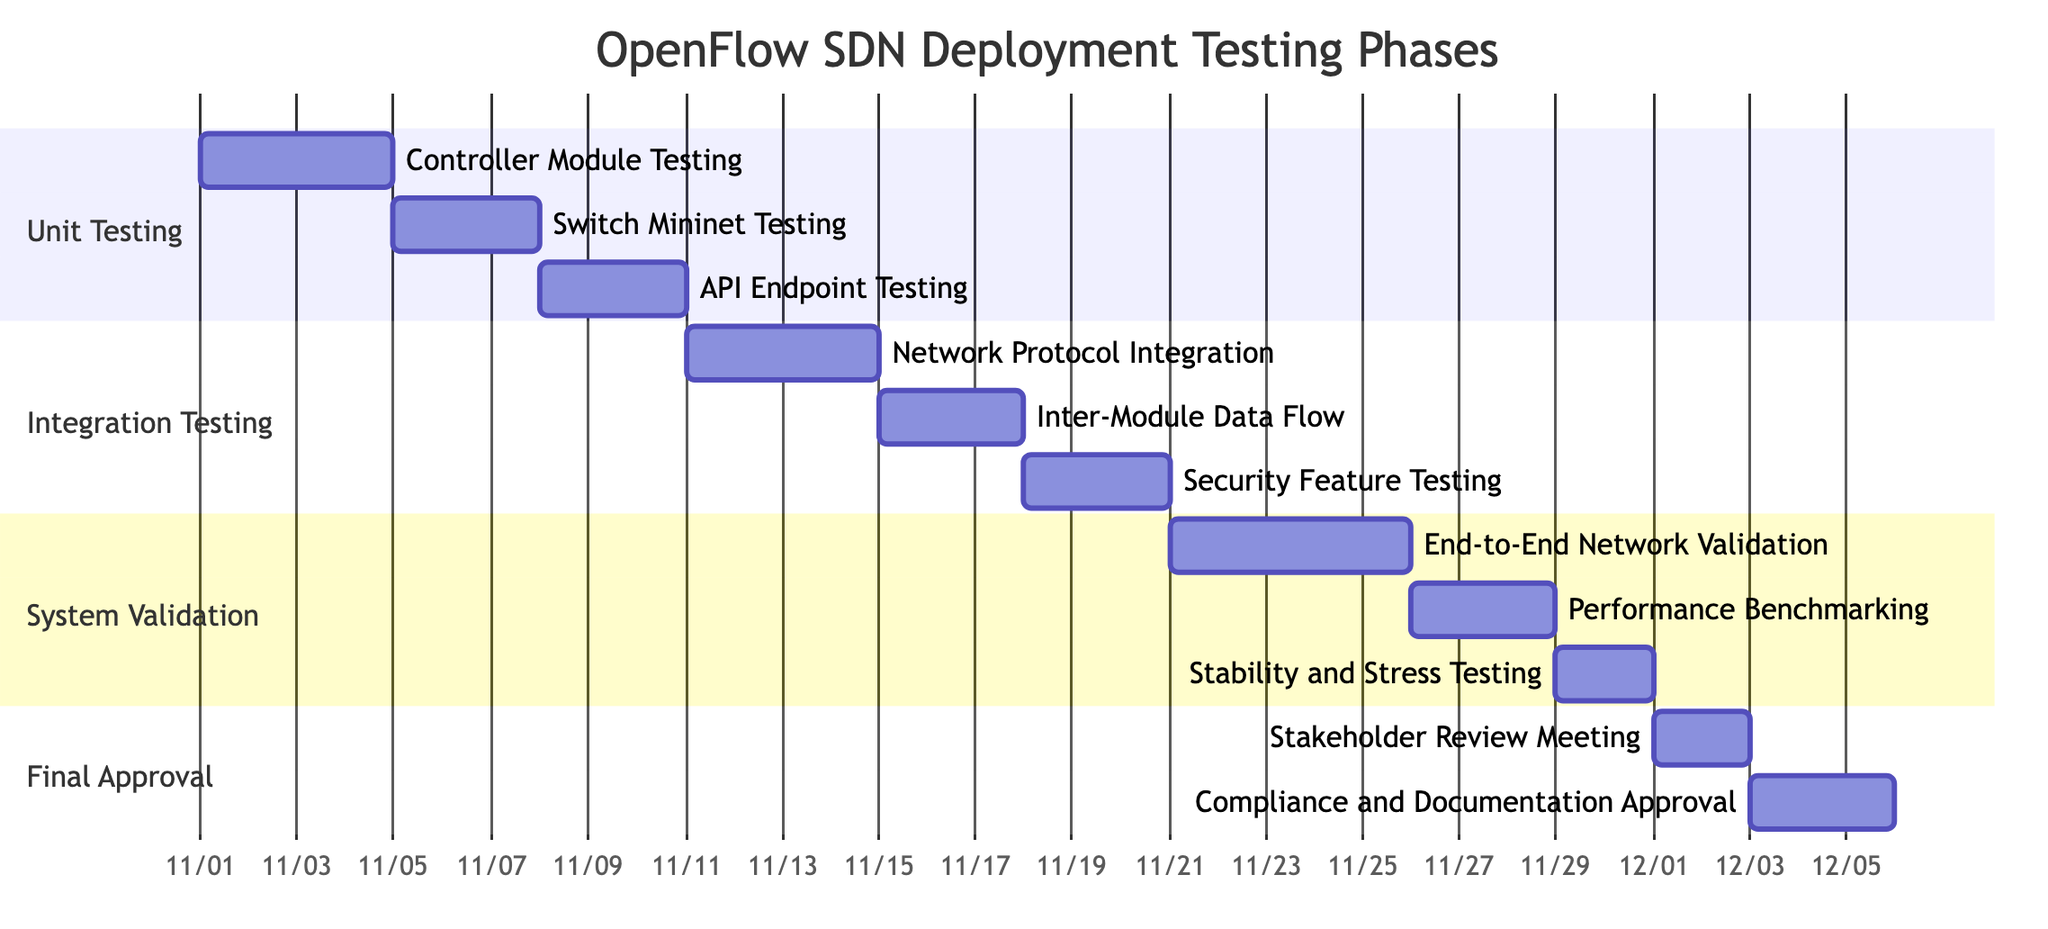What is the duration of Unit Testing? Unit Testing starts on November 1, 2023, and ends on November 10, 2023, which gives it a duration of 10 days.
Answer: 10 days Which task has the latest end date? The final task, 'Compliance and Documentation Approval', ends on December 5, 2023, which is later than all other tasks.
Answer: December 5, 2023 How many subtasks are in Integration Testing? Integration Testing has three subtasks: 'Network Protocol Integration', 'Inter-Module Data Flow', and 'Security Feature Testing'.
Answer: 3 What is the start date of Stability and Stress Testing? Stability and Stress Testing is a subtask of System Validation, and it starts on November 29, 2023.
Answer: November 29, 2023 Which phase includes Performance Benchmarking? Performance Benchmarking is included in the System Validation phase, indicated by its grouping under the section labeled 'System Validation'.
Answer: System Validation What is the relationship between Unit Testing and Integration Testing in terms of sequence? Unit Testing is completed before Integration Testing begins since Unit Testing finishes on November 10, 2023, and Integration Testing starts on November 11, 2023.
Answer: Sequential How long does the Final Approval phase last? Final Approval starts on December 1, 2023, and ends on December 5, 2023, resulting in a duration of 5 days.
Answer: 5 days What task starts immediately after Inter-Module Data Flow? The task 'Security Feature Testing' starts immediately after 'Inter-Module Data Flow', as it begins on November 18, 2023, which follows the end date of November 17, 2023.
Answer: Security Feature Testing Which testing phase includes End-to-End Network Validation? End-to-End Network Validation is part of the System Validation phase, as it is listed as the first subtask under this section.
Answer: System Validation 